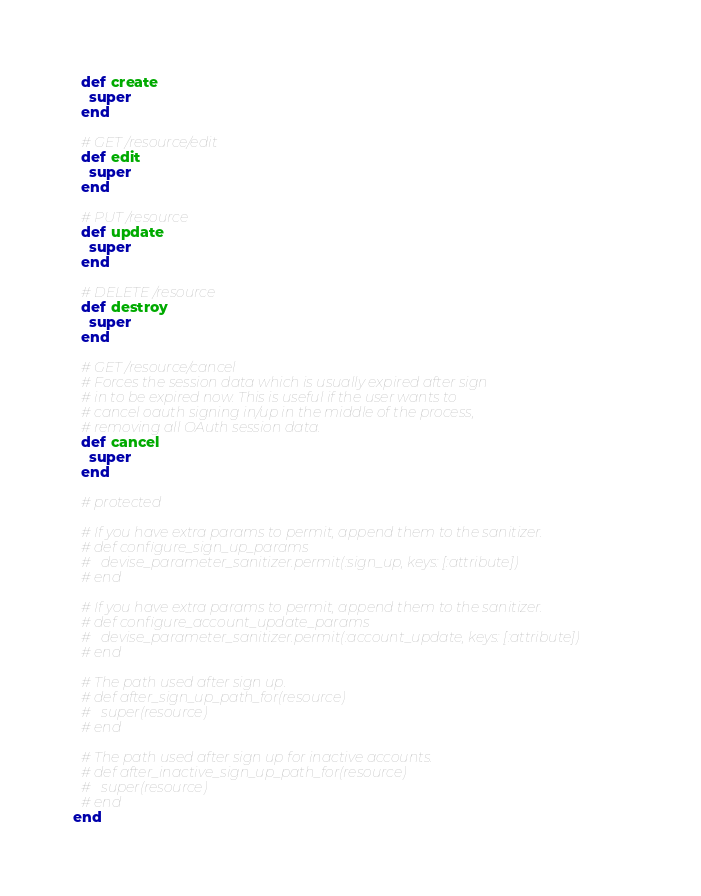<code> <loc_0><loc_0><loc_500><loc_500><_Ruby_>  def create
    super
  end

  # GET /resource/edit
  def edit
    super
  end

  # PUT /resource
  def update
    super
  end

  # DELETE /resource
  def destroy
    super
  end

  # GET /resource/cancel
  # Forces the session data which is usually expired after sign
  # in to be expired now. This is useful if the user wants to
  # cancel oauth signing in/up in the middle of the process,
  # removing all OAuth session data.
  def cancel
    super
  end

  # protected

  # If you have extra params to permit, append them to the sanitizer.
  # def configure_sign_up_params
  #   devise_parameter_sanitizer.permit(:sign_up, keys: [:attribute])
  # end

  # If you have extra params to permit, append them to the sanitizer.
  # def configure_account_update_params
  #   devise_parameter_sanitizer.permit(:account_update, keys: [:attribute])
  # end

  # The path used after sign up.
  # def after_sign_up_path_for(resource)
  #   super(resource)
  # end

  # The path used after sign up for inactive accounts.
  # def after_inactive_sign_up_path_for(resource)
  #   super(resource)
  # end
end
</code> 